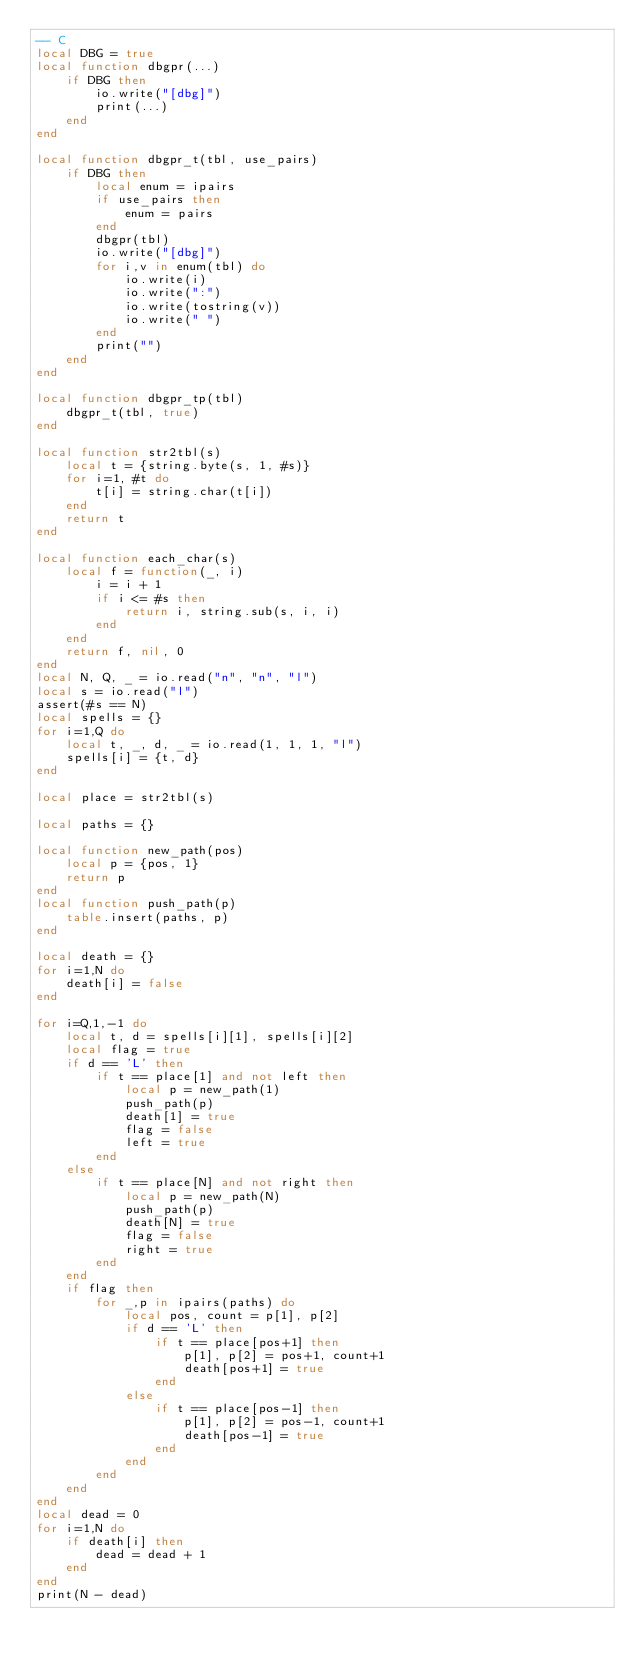Convert code to text. <code><loc_0><loc_0><loc_500><loc_500><_Lua_>-- C
local DBG = true
local function dbgpr(...)
    if DBG then
        io.write("[dbg]")
        print(...)
    end
end

local function dbgpr_t(tbl, use_pairs)
    if DBG then
        local enum = ipairs
        if use_pairs then
            enum = pairs
        end
        dbgpr(tbl)
        io.write("[dbg]")
        for i,v in enum(tbl) do
            io.write(i)
            io.write(":")
            io.write(tostring(v))
            io.write(" ")
        end
        print("")
    end
end

local function dbgpr_tp(tbl)
    dbgpr_t(tbl, true)
end

local function str2tbl(s)
    local t = {string.byte(s, 1, #s)}
    for i=1, #t do
        t[i] = string.char(t[i])
    end
    return t
end

local function each_char(s)
    local f = function(_, i)
        i = i + 1
        if i <= #s then
            return i, string.sub(s, i, i)
        end
    end
    return f, nil, 0
end
local N, Q, _ = io.read("n", "n", "l")
local s = io.read("l")
assert(#s == N)
local spells = {}
for i=1,Q do
    local t, _, d, _ = io.read(1, 1, 1, "l")
    spells[i] = {t, d}
end

local place = str2tbl(s)

local paths = {}

local function new_path(pos)
    local p = {pos, 1}
    return p
end
local function push_path(p)
    table.insert(paths, p)
end

local death = {}
for i=1,N do
    death[i] = false
end

for i=Q,1,-1 do
    local t, d = spells[i][1], spells[i][2]
    local flag = true
    if d == 'L' then
        if t == place[1] and not left then
            local p = new_path(1)
            push_path(p)
            death[1] = true
            flag = false
            left = true
        end
    else
        if t == place[N] and not right then
            local p = new_path(N)
            push_path(p)
            death[N] = true
            flag = false
            right = true
        end
    end
    if flag then
        for _,p in ipairs(paths) do
            local pos, count = p[1], p[2]
            if d == 'L' then
                if t == place[pos+1] then
                    p[1], p[2] = pos+1, count+1
                    death[pos+1] = true
                end
            else
                if t == place[pos-1] then
                    p[1], p[2] = pos-1, count+1
                    death[pos-1] = true
                end
            end
        end
    end
end
local dead = 0
for i=1,N do
    if death[i] then
        dead = dead + 1
    end
end
print(N - dead)</code> 